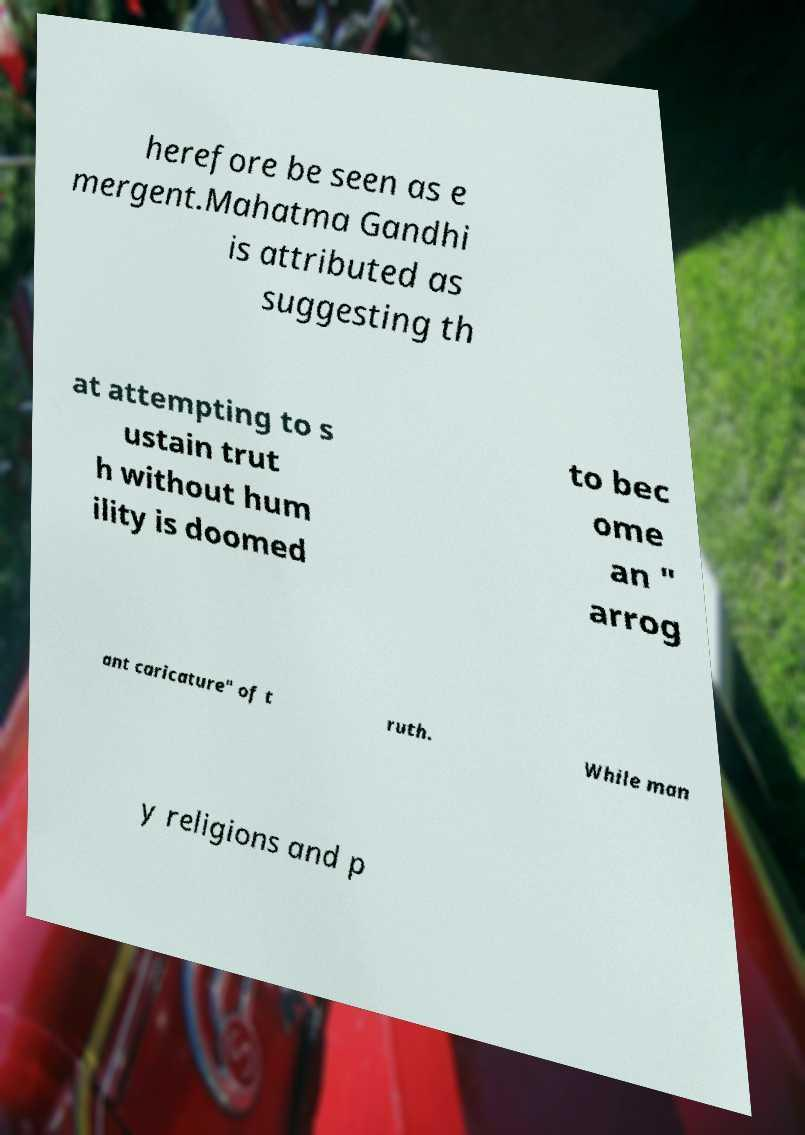Could you assist in decoding the text presented in this image and type it out clearly? herefore be seen as e mergent.Mahatma Gandhi is attributed as suggesting th at attempting to s ustain trut h without hum ility is doomed to bec ome an " arrog ant caricature" of t ruth. While man y religions and p 